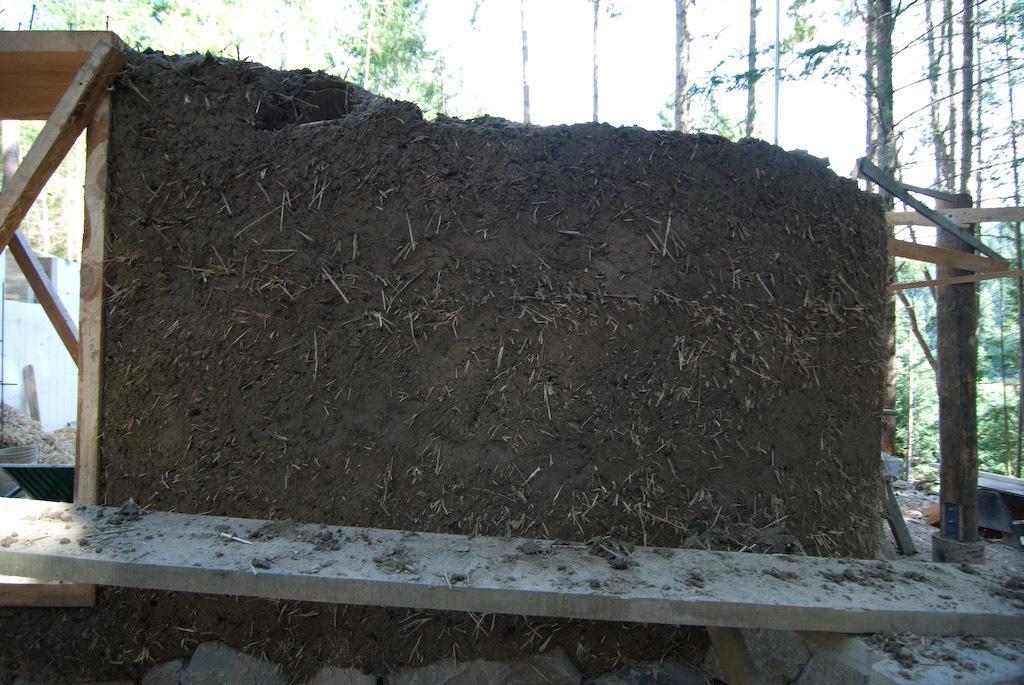Describe this image in one or two sentences. In this image we can see a wall with mud, there are wooden planks, trees in the background. 